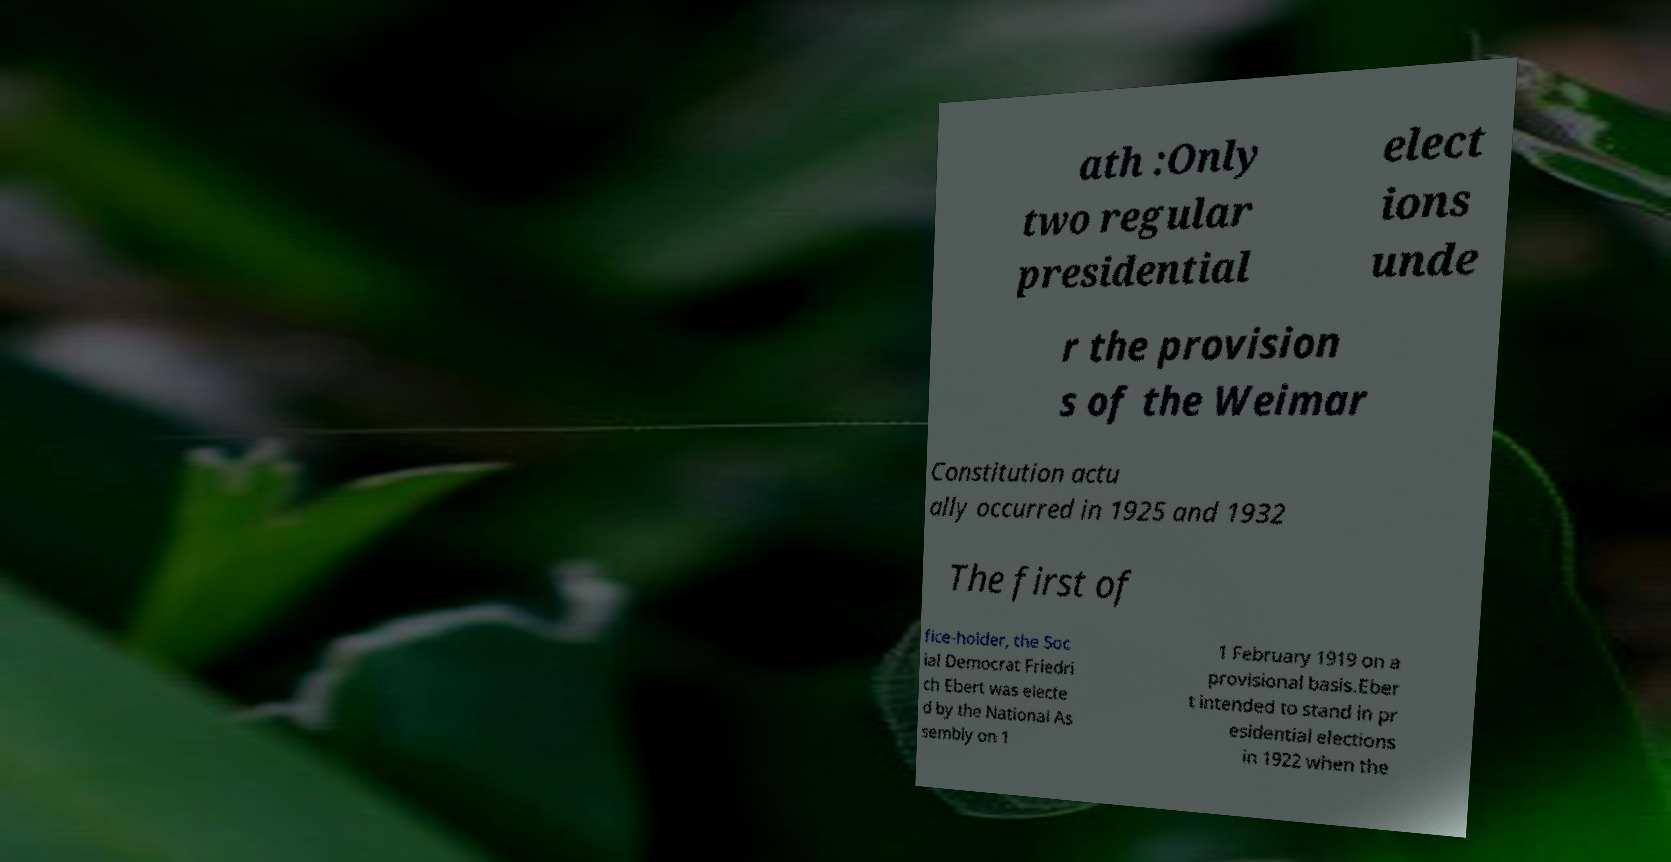There's text embedded in this image that I need extracted. Can you transcribe it verbatim? ath :Only two regular presidential elect ions unde r the provision s of the Weimar Constitution actu ally occurred in 1925 and 1932 The first of fice-holder, the Soc ial Democrat Friedri ch Ebert was electe d by the National As sembly on 1 1 February 1919 on a provisional basis.Eber t intended to stand in pr esidential elections in 1922 when the 